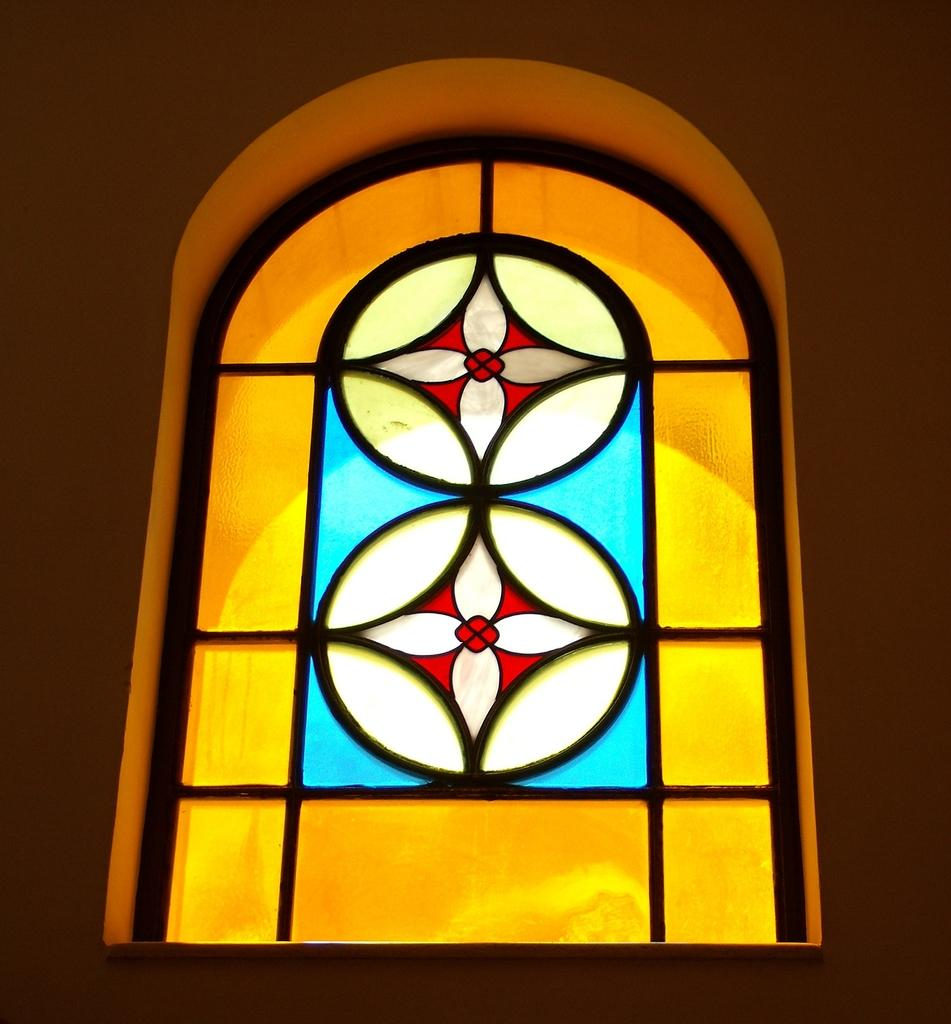What is the appearance of the window in the image? The window in the image is grilled and has yellow, blue, and red colors. What can be seen in the background of the image? There is a wall in the image. What is the color of the wall? The wall is white. Can you describe the lighting conditions in the image? The image might have been taken in a dark environment. What type of wine is being served in the image? There is no wine present in the image; it features a grilled window with yellow, blue, and red colors, a white wall, and possibly a dark environment. 